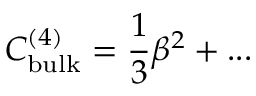<formula> <loc_0><loc_0><loc_500><loc_500>C _ { b u l k } ^ { ( 4 ) } = \frac { 1 } { 3 } \beta ^ { 2 } + \dots</formula> 